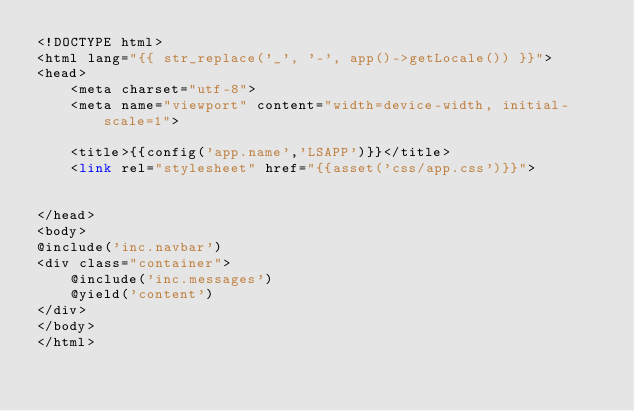Convert code to text. <code><loc_0><loc_0><loc_500><loc_500><_PHP_><!DOCTYPE html>
<html lang="{{ str_replace('_', '-', app()->getLocale()) }}">
<head>
    <meta charset="utf-8">
    <meta name="viewport" content="width=device-width, initial-scale=1">

    <title>{{config('app.name','LSAPP')}}</title>
    <link rel="stylesheet" href="{{asset('css/app.css')}}">


</head>
<body>
@include('inc.navbar')
<div class="container">
    @include('inc.messages')
    @yield('content')
</div>
</body>
</html>
</code> 